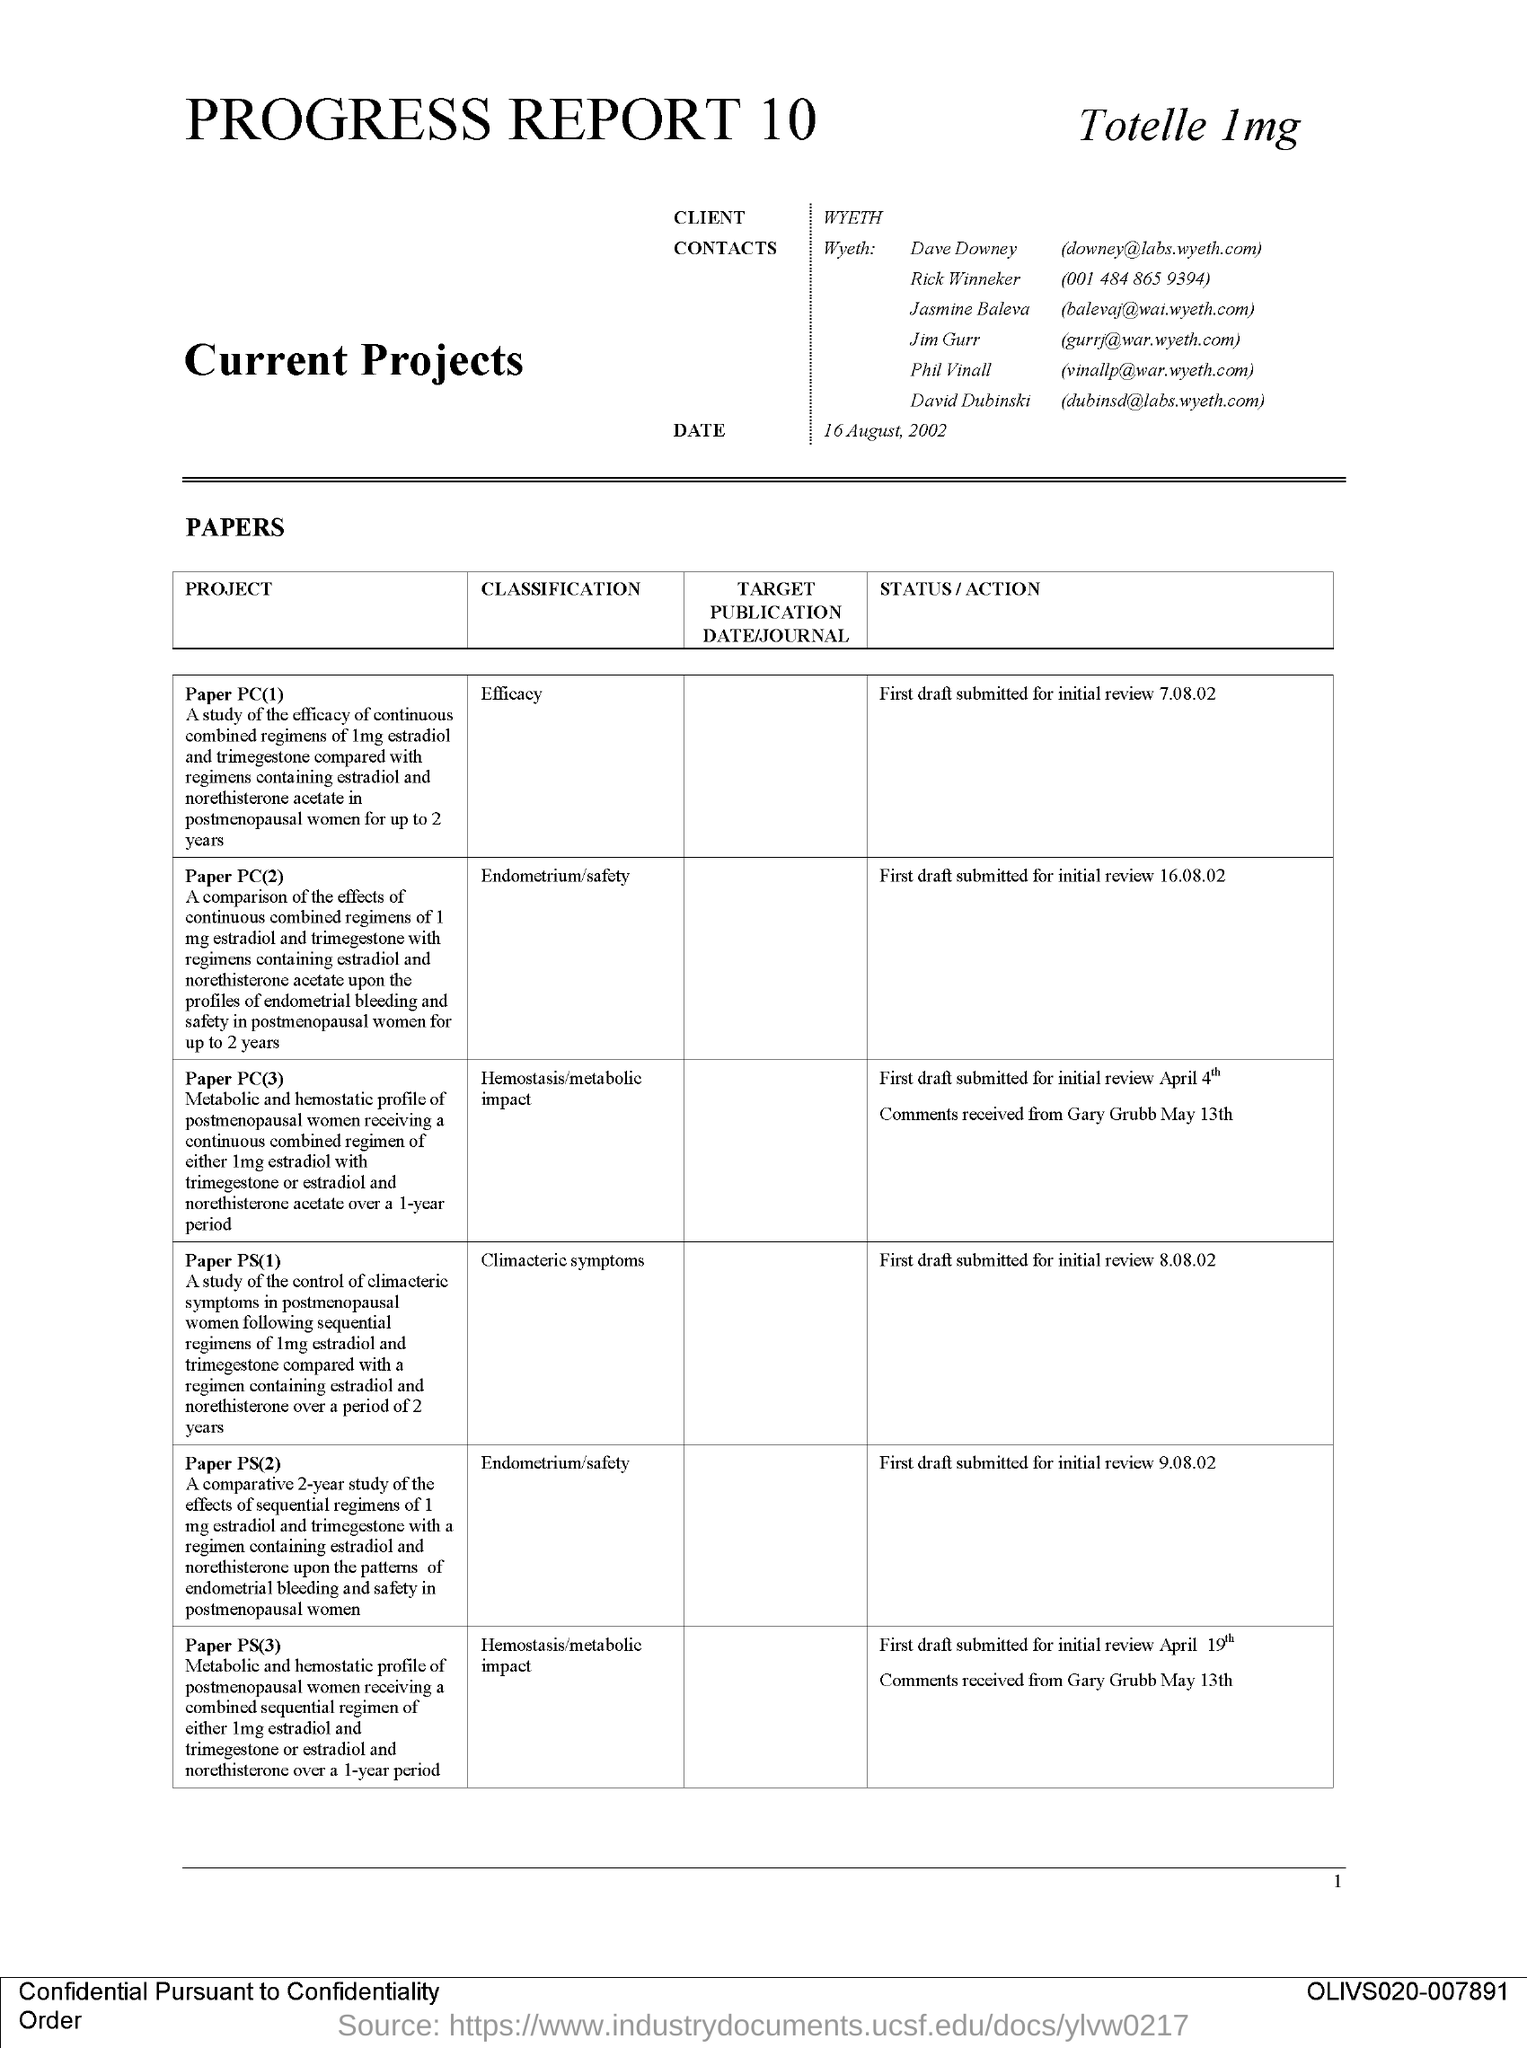Point out several critical features in this image. I do not know the telephone number of Rick Winneker. It is 001 484 865 9394. Classification for Paper PS(1) mentions climacteric symptoms. The classification for Paper PS(3) includes hemostasis/metabolic impact. The client's name is Wyeth. The code number mentioned on the right bottom of the page is olivs020-007891. 